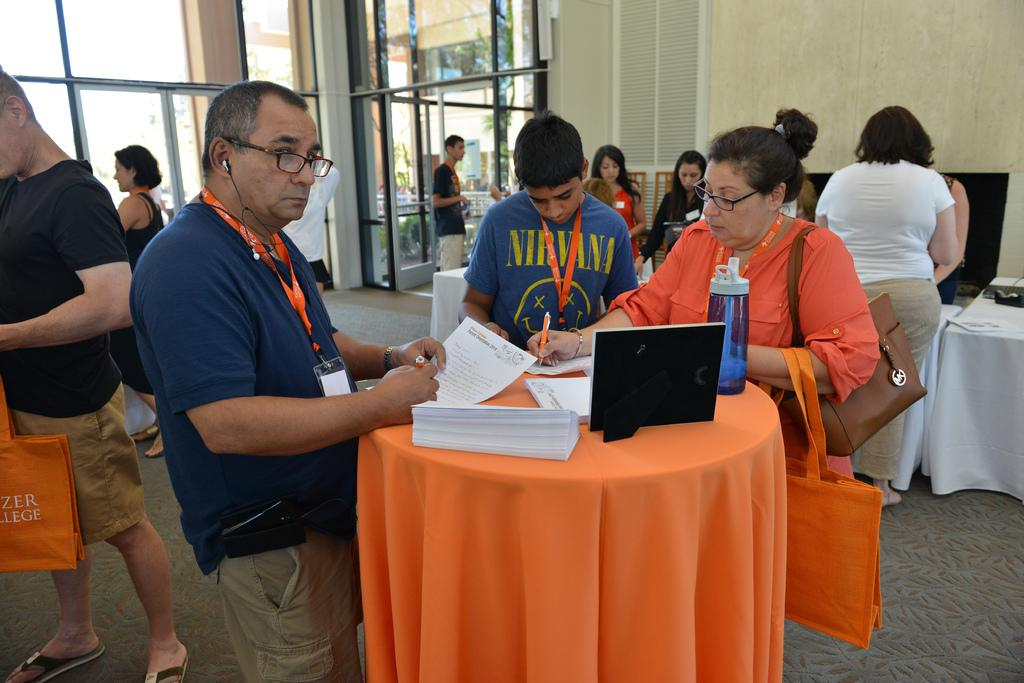What are the people in the image doing? The persons standing on the floor are likely engaged in some activity or conversation. What objects can be seen on the tables in the image? There are papers and a bottle on the table. What type of structure is present in the image? There is a door and a wall in the image. What type of animal can be seen playing with the papers on the table? There are no animals present in the image, and therefore no such activity can be observed. 